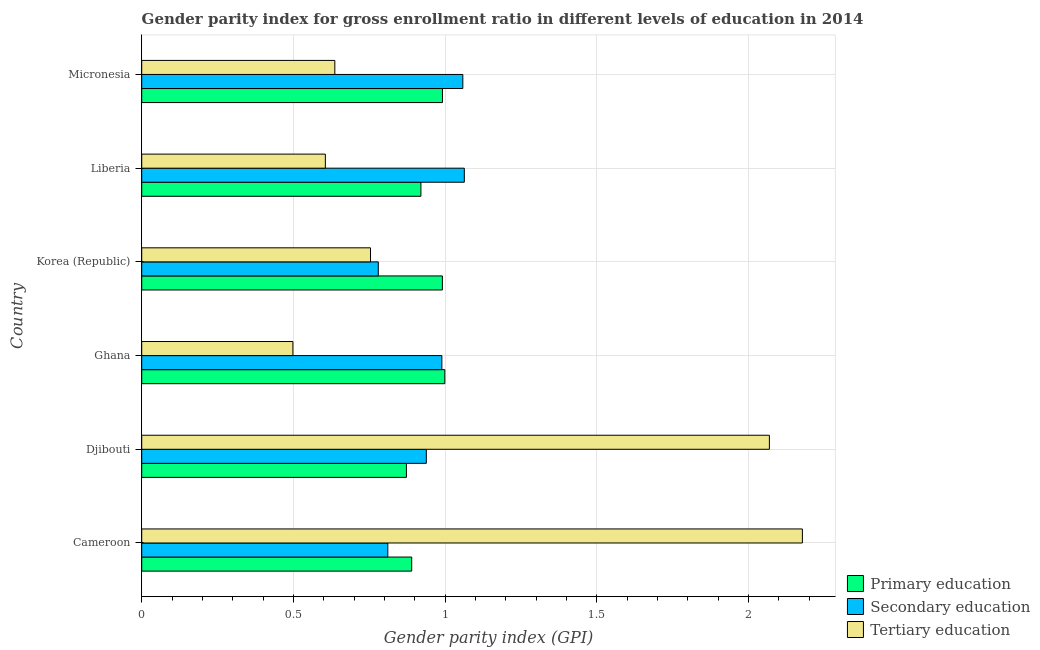How many different coloured bars are there?
Offer a very short reply. 3. Are the number of bars on each tick of the Y-axis equal?
Your answer should be compact. Yes. How many bars are there on the 4th tick from the top?
Keep it short and to the point. 3. How many bars are there on the 2nd tick from the bottom?
Provide a succinct answer. 3. What is the label of the 5th group of bars from the top?
Provide a succinct answer. Djibouti. What is the gender parity index in tertiary education in Micronesia?
Keep it short and to the point. 0.64. Across all countries, what is the maximum gender parity index in primary education?
Ensure brevity in your answer.  1. Across all countries, what is the minimum gender parity index in primary education?
Give a very brief answer. 0.87. In which country was the gender parity index in tertiary education maximum?
Your answer should be compact. Cameroon. What is the total gender parity index in primary education in the graph?
Provide a short and direct response. 5.66. What is the difference between the gender parity index in tertiary education in Cameroon and that in Korea (Republic)?
Keep it short and to the point. 1.42. What is the difference between the gender parity index in primary education in Djibouti and the gender parity index in secondary education in Liberia?
Ensure brevity in your answer.  -0.19. What is the average gender parity index in tertiary education per country?
Provide a short and direct response. 1.12. What is the difference between the gender parity index in tertiary education and gender parity index in secondary education in Liberia?
Ensure brevity in your answer.  -0.46. What is the ratio of the gender parity index in tertiary education in Ghana to that in Liberia?
Offer a terse response. 0.82. What is the difference between the highest and the second highest gender parity index in primary education?
Offer a terse response. 0.01. What is the difference between the highest and the lowest gender parity index in primary education?
Make the answer very short. 0.13. In how many countries, is the gender parity index in secondary education greater than the average gender parity index in secondary education taken over all countries?
Offer a terse response. 3. What does the 1st bar from the top in Djibouti represents?
Make the answer very short. Tertiary education. What does the 3rd bar from the bottom in Cameroon represents?
Your answer should be very brief. Tertiary education. How many bars are there?
Provide a succinct answer. 18. How many countries are there in the graph?
Ensure brevity in your answer.  6. What is the difference between two consecutive major ticks on the X-axis?
Give a very brief answer. 0.5. Are the values on the major ticks of X-axis written in scientific E-notation?
Ensure brevity in your answer.  No. Does the graph contain grids?
Ensure brevity in your answer.  Yes. How many legend labels are there?
Offer a terse response. 3. How are the legend labels stacked?
Your answer should be very brief. Vertical. What is the title of the graph?
Your answer should be very brief. Gender parity index for gross enrollment ratio in different levels of education in 2014. Does "Consumption Tax" appear as one of the legend labels in the graph?
Offer a terse response. No. What is the label or title of the X-axis?
Provide a succinct answer. Gender parity index (GPI). What is the Gender parity index (GPI) of Primary education in Cameroon?
Your response must be concise. 0.89. What is the Gender parity index (GPI) in Secondary education in Cameroon?
Offer a terse response. 0.81. What is the Gender parity index (GPI) of Tertiary education in Cameroon?
Provide a short and direct response. 2.18. What is the Gender parity index (GPI) in Primary education in Djibouti?
Your response must be concise. 0.87. What is the Gender parity index (GPI) in Secondary education in Djibouti?
Provide a succinct answer. 0.94. What is the Gender parity index (GPI) in Tertiary education in Djibouti?
Make the answer very short. 2.07. What is the Gender parity index (GPI) in Primary education in Ghana?
Give a very brief answer. 1. What is the Gender parity index (GPI) of Secondary education in Ghana?
Ensure brevity in your answer.  0.99. What is the Gender parity index (GPI) in Tertiary education in Ghana?
Your response must be concise. 0.5. What is the Gender parity index (GPI) in Primary education in Korea (Republic)?
Your answer should be very brief. 0.99. What is the Gender parity index (GPI) of Secondary education in Korea (Republic)?
Give a very brief answer. 0.78. What is the Gender parity index (GPI) of Tertiary education in Korea (Republic)?
Provide a succinct answer. 0.75. What is the Gender parity index (GPI) in Primary education in Liberia?
Your response must be concise. 0.92. What is the Gender parity index (GPI) in Secondary education in Liberia?
Make the answer very short. 1.06. What is the Gender parity index (GPI) in Tertiary education in Liberia?
Keep it short and to the point. 0.61. What is the Gender parity index (GPI) of Primary education in Micronesia?
Your answer should be compact. 0.99. What is the Gender parity index (GPI) of Secondary education in Micronesia?
Keep it short and to the point. 1.06. What is the Gender parity index (GPI) in Tertiary education in Micronesia?
Offer a terse response. 0.64. Across all countries, what is the maximum Gender parity index (GPI) in Primary education?
Give a very brief answer. 1. Across all countries, what is the maximum Gender parity index (GPI) of Secondary education?
Make the answer very short. 1.06. Across all countries, what is the maximum Gender parity index (GPI) of Tertiary education?
Provide a succinct answer. 2.18. Across all countries, what is the minimum Gender parity index (GPI) of Primary education?
Keep it short and to the point. 0.87. Across all countries, what is the minimum Gender parity index (GPI) of Secondary education?
Provide a short and direct response. 0.78. Across all countries, what is the minimum Gender parity index (GPI) in Tertiary education?
Offer a terse response. 0.5. What is the total Gender parity index (GPI) of Primary education in the graph?
Your answer should be very brief. 5.66. What is the total Gender parity index (GPI) in Secondary education in the graph?
Ensure brevity in your answer.  5.64. What is the total Gender parity index (GPI) of Tertiary education in the graph?
Provide a succinct answer. 6.74. What is the difference between the Gender parity index (GPI) in Primary education in Cameroon and that in Djibouti?
Keep it short and to the point. 0.02. What is the difference between the Gender parity index (GPI) in Secondary education in Cameroon and that in Djibouti?
Provide a short and direct response. -0.13. What is the difference between the Gender parity index (GPI) of Tertiary education in Cameroon and that in Djibouti?
Ensure brevity in your answer.  0.11. What is the difference between the Gender parity index (GPI) of Primary education in Cameroon and that in Ghana?
Make the answer very short. -0.11. What is the difference between the Gender parity index (GPI) in Secondary education in Cameroon and that in Ghana?
Offer a very short reply. -0.18. What is the difference between the Gender parity index (GPI) in Tertiary education in Cameroon and that in Ghana?
Ensure brevity in your answer.  1.68. What is the difference between the Gender parity index (GPI) in Primary education in Cameroon and that in Korea (Republic)?
Offer a terse response. -0.1. What is the difference between the Gender parity index (GPI) in Secondary education in Cameroon and that in Korea (Republic)?
Offer a terse response. 0.03. What is the difference between the Gender parity index (GPI) in Tertiary education in Cameroon and that in Korea (Republic)?
Offer a very short reply. 1.42. What is the difference between the Gender parity index (GPI) of Primary education in Cameroon and that in Liberia?
Provide a short and direct response. -0.03. What is the difference between the Gender parity index (GPI) in Secondary education in Cameroon and that in Liberia?
Offer a very short reply. -0.25. What is the difference between the Gender parity index (GPI) of Tertiary education in Cameroon and that in Liberia?
Keep it short and to the point. 1.57. What is the difference between the Gender parity index (GPI) of Primary education in Cameroon and that in Micronesia?
Provide a succinct answer. -0.1. What is the difference between the Gender parity index (GPI) in Secondary education in Cameroon and that in Micronesia?
Your response must be concise. -0.25. What is the difference between the Gender parity index (GPI) in Tertiary education in Cameroon and that in Micronesia?
Your answer should be very brief. 1.54. What is the difference between the Gender parity index (GPI) of Primary education in Djibouti and that in Ghana?
Your answer should be very brief. -0.13. What is the difference between the Gender parity index (GPI) of Secondary education in Djibouti and that in Ghana?
Offer a terse response. -0.05. What is the difference between the Gender parity index (GPI) of Tertiary education in Djibouti and that in Ghana?
Ensure brevity in your answer.  1.57. What is the difference between the Gender parity index (GPI) in Primary education in Djibouti and that in Korea (Republic)?
Ensure brevity in your answer.  -0.12. What is the difference between the Gender parity index (GPI) of Secondary education in Djibouti and that in Korea (Republic)?
Offer a very short reply. 0.16. What is the difference between the Gender parity index (GPI) of Tertiary education in Djibouti and that in Korea (Republic)?
Give a very brief answer. 1.31. What is the difference between the Gender parity index (GPI) in Primary education in Djibouti and that in Liberia?
Your response must be concise. -0.05. What is the difference between the Gender parity index (GPI) of Secondary education in Djibouti and that in Liberia?
Your answer should be very brief. -0.13. What is the difference between the Gender parity index (GPI) of Tertiary education in Djibouti and that in Liberia?
Keep it short and to the point. 1.46. What is the difference between the Gender parity index (GPI) in Primary education in Djibouti and that in Micronesia?
Ensure brevity in your answer.  -0.12. What is the difference between the Gender parity index (GPI) of Secondary education in Djibouti and that in Micronesia?
Your response must be concise. -0.12. What is the difference between the Gender parity index (GPI) in Tertiary education in Djibouti and that in Micronesia?
Offer a terse response. 1.43. What is the difference between the Gender parity index (GPI) of Primary education in Ghana and that in Korea (Republic)?
Provide a short and direct response. 0.01. What is the difference between the Gender parity index (GPI) of Secondary education in Ghana and that in Korea (Republic)?
Provide a succinct answer. 0.21. What is the difference between the Gender parity index (GPI) of Tertiary education in Ghana and that in Korea (Republic)?
Provide a short and direct response. -0.26. What is the difference between the Gender parity index (GPI) of Primary education in Ghana and that in Liberia?
Ensure brevity in your answer.  0.08. What is the difference between the Gender parity index (GPI) in Secondary education in Ghana and that in Liberia?
Your response must be concise. -0.07. What is the difference between the Gender parity index (GPI) of Tertiary education in Ghana and that in Liberia?
Offer a terse response. -0.11. What is the difference between the Gender parity index (GPI) of Primary education in Ghana and that in Micronesia?
Your answer should be very brief. 0.01. What is the difference between the Gender parity index (GPI) of Secondary education in Ghana and that in Micronesia?
Provide a short and direct response. -0.07. What is the difference between the Gender parity index (GPI) of Tertiary education in Ghana and that in Micronesia?
Your response must be concise. -0.14. What is the difference between the Gender parity index (GPI) in Primary education in Korea (Republic) and that in Liberia?
Give a very brief answer. 0.07. What is the difference between the Gender parity index (GPI) in Secondary education in Korea (Republic) and that in Liberia?
Your answer should be compact. -0.28. What is the difference between the Gender parity index (GPI) of Tertiary education in Korea (Republic) and that in Liberia?
Keep it short and to the point. 0.15. What is the difference between the Gender parity index (GPI) in Primary education in Korea (Republic) and that in Micronesia?
Offer a very short reply. -0. What is the difference between the Gender parity index (GPI) in Secondary education in Korea (Republic) and that in Micronesia?
Make the answer very short. -0.28. What is the difference between the Gender parity index (GPI) in Tertiary education in Korea (Republic) and that in Micronesia?
Give a very brief answer. 0.12. What is the difference between the Gender parity index (GPI) of Primary education in Liberia and that in Micronesia?
Keep it short and to the point. -0.07. What is the difference between the Gender parity index (GPI) in Secondary education in Liberia and that in Micronesia?
Make the answer very short. 0. What is the difference between the Gender parity index (GPI) in Tertiary education in Liberia and that in Micronesia?
Your answer should be compact. -0.03. What is the difference between the Gender parity index (GPI) of Primary education in Cameroon and the Gender parity index (GPI) of Secondary education in Djibouti?
Give a very brief answer. -0.05. What is the difference between the Gender parity index (GPI) in Primary education in Cameroon and the Gender parity index (GPI) in Tertiary education in Djibouti?
Your answer should be compact. -1.18. What is the difference between the Gender parity index (GPI) in Secondary education in Cameroon and the Gender parity index (GPI) in Tertiary education in Djibouti?
Offer a very short reply. -1.26. What is the difference between the Gender parity index (GPI) of Primary education in Cameroon and the Gender parity index (GPI) of Secondary education in Ghana?
Your answer should be compact. -0.1. What is the difference between the Gender parity index (GPI) of Primary education in Cameroon and the Gender parity index (GPI) of Tertiary education in Ghana?
Keep it short and to the point. 0.39. What is the difference between the Gender parity index (GPI) of Secondary education in Cameroon and the Gender parity index (GPI) of Tertiary education in Ghana?
Provide a short and direct response. 0.31. What is the difference between the Gender parity index (GPI) in Primary education in Cameroon and the Gender parity index (GPI) in Secondary education in Korea (Republic)?
Ensure brevity in your answer.  0.11. What is the difference between the Gender parity index (GPI) of Primary education in Cameroon and the Gender parity index (GPI) of Tertiary education in Korea (Republic)?
Make the answer very short. 0.14. What is the difference between the Gender parity index (GPI) of Secondary education in Cameroon and the Gender parity index (GPI) of Tertiary education in Korea (Republic)?
Your response must be concise. 0.06. What is the difference between the Gender parity index (GPI) of Primary education in Cameroon and the Gender parity index (GPI) of Secondary education in Liberia?
Provide a short and direct response. -0.17. What is the difference between the Gender parity index (GPI) of Primary education in Cameroon and the Gender parity index (GPI) of Tertiary education in Liberia?
Provide a short and direct response. 0.28. What is the difference between the Gender parity index (GPI) of Secondary education in Cameroon and the Gender parity index (GPI) of Tertiary education in Liberia?
Provide a succinct answer. 0.21. What is the difference between the Gender parity index (GPI) in Primary education in Cameroon and the Gender parity index (GPI) in Secondary education in Micronesia?
Your answer should be compact. -0.17. What is the difference between the Gender parity index (GPI) of Primary education in Cameroon and the Gender parity index (GPI) of Tertiary education in Micronesia?
Ensure brevity in your answer.  0.25. What is the difference between the Gender parity index (GPI) of Secondary education in Cameroon and the Gender parity index (GPI) of Tertiary education in Micronesia?
Your answer should be very brief. 0.17. What is the difference between the Gender parity index (GPI) of Primary education in Djibouti and the Gender parity index (GPI) of Secondary education in Ghana?
Give a very brief answer. -0.12. What is the difference between the Gender parity index (GPI) in Primary education in Djibouti and the Gender parity index (GPI) in Tertiary education in Ghana?
Your answer should be compact. 0.37. What is the difference between the Gender parity index (GPI) of Secondary education in Djibouti and the Gender parity index (GPI) of Tertiary education in Ghana?
Your answer should be compact. 0.44. What is the difference between the Gender parity index (GPI) in Primary education in Djibouti and the Gender parity index (GPI) in Secondary education in Korea (Republic)?
Offer a terse response. 0.09. What is the difference between the Gender parity index (GPI) in Primary education in Djibouti and the Gender parity index (GPI) in Tertiary education in Korea (Republic)?
Make the answer very short. 0.12. What is the difference between the Gender parity index (GPI) of Secondary education in Djibouti and the Gender parity index (GPI) of Tertiary education in Korea (Republic)?
Offer a very short reply. 0.18. What is the difference between the Gender parity index (GPI) of Primary education in Djibouti and the Gender parity index (GPI) of Secondary education in Liberia?
Give a very brief answer. -0.19. What is the difference between the Gender parity index (GPI) of Primary education in Djibouti and the Gender parity index (GPI) of Tertiary education in Liberia?
Your answer should be very brief. 0.27. What is the difference between the Gender parity index (GPI) in Secondary education in Djibouti and the Gender parity index (GPI) in Tertiary education in Liberia?
Offer a very short reply. 0.33. What is the difference between the Gender parity index (GPI) of Primary education in Djibouti and the Gender parity index (GPI) of Secondary education in Micronesia?
Provide a succinct answer. -0.19. What is the difference between the Gender parity index (GPI) in Primary education in Djibouti and the Gender parity index (GPI) in Tertiary education in Micronesia?
Your answer should be compact. 0.24. What is the difference between the Gender parity index (GPI) of Secondary education in Djibouti and the Gender parity index (GPI) of Tertiary education in Micronesia?
Offer a very short reply. 0.3. What is the difference between the Gender parity index (GPI) in Primary education in Ghana and the Gender parity index (GPI) in Secondary education in Korea (Republic)?
Offer a terse response. 0.22. What is the difference between the Gender parity index (GPI) in Primary education in Ghana and the Gender parity index (GPI) in Tertiary education in Korea (Republic)?
Your response must be concise. 0.24. What is the difference between the Gender parity index (GPI) of Secondary education in Ghana and the Gender parity index (GPI) of Tertiary education in Korea (Republic)?
Give a very brief answer. 0.24. What is the difference between the Gender parity index (GPI) of Primary education in Ghana and the Gender parity index (GPI) of Secondary education in Liberia?
Give a very brief answer. -0.06. What is the difference between the Gender parity index (GPI) of Primary education in Ghana and the Gender parity index (GPI) of Tertiary education in Liberia?
Your answer should be very brief. 0.39. What is the difference between the Gender parity index (GPI) in Secondary education in Ghana and the Gender parity index (GPI) in Tertiary education in Liberia?
Ensure brevity in your answer.  0.38. What is the difference between the Gender parity index (GPI) in Primary education in Ghana and the Gender parity index (GPI) in Secondary education in Micronesia?
Make the answer very short. -0.06. What is the difference between the Gender parity index (GPI) of Primary education in Ghana and the Gender parity index (GPI) of Tertiary education in Micronesia?
Keep it short and to the point. 0.36. What is the difference between the Gender parity index (GPI) of Secondary education in Ghana and the Gender parity index (GPI) of Tertiary education in Micronesia?
Your response must be concise. 0.35. What is the difference between the Gender parity index (GPI) of Primary education in Korea (Republic) and the Gender parity index (GPI) of Secondary education in Liberia?
Keep it short and to the point. -0.07. What is the difference between the Gender parity index (GPI) in Primary education in Korea (Republic) and the Gender parity index (GPI) in Tertiary education in Liberia?
Provide a succinct answer. 0.39. What is the difference between the Gender parity index (GPI) in Secondary education in Korea (Republic) and the Gender parity index (GPI) in Tertiary education in Liberia?
Make the answer very short. 0.17. What is the difference between the Gender parity index (GPI) of Primary education in Korea (Republic) and the Gender parity index (GPI) of Secondary education in Micronesia?
Provide a succinct answer. -0.07. What is the difference between the Gender parity index (GPI) of Primary education in Korea (Republic) and the Gender parity index (GPI) of Tertiary education in Micronesia?
Provide a short and direct response. 0.35. What is the difference between the Gender parity index (GPI) of Secondary education in Korea (Republic) and the Gender parity index (GPI) of Tertiary education in Micronesia?
Ensure brevity in your answer.  0.14. What is the difference between the Gender parity index (GPI) of Primary education in Liberia and the Gender parity index (GPI) of Secondary education in Micronesia?
Provide a succinct answer. -0.14. What is the difference between the Gender parity index (GPI) in Primary education in Liberia and the Gender parity index (GPI) in Tertiary education in Micronesia?
Offer a very short reply. 0.28. What is the difference between the Gender parity index (GPI) of Secondary education in Liberia and the Gender parity index (GPI) of Tertiary education in Micronesia?
Offer a terse response. 0.43. What is the average Gender parity index (GPI) in Primary education per country?
Ensure brevity in your answer.  0.94. What is the average Gender parity index (GPI) in Secondary education per country?
Offer a terse response. 0.94. What is the average Gender parity index (GPI) of Tertiary education per country?
Give a very brief answer. 1.12. What is the difference between the Gender parity index (GPI) in Primary education and Gender parity index (GPI) in Secondary education in Cameroon?
Offer a terse response. 0.08. What is the difference between the Gender parity index (GPI) of Primary education and Gender parity index (GPI) of Tertiary education in Cameroon?
Your response must be concise. -1.29. What is the difference between the Gender parity index (GPI) in Secondary education and Gender parity index (GPI) in Tertiary education in Cameroon?
Offer a very short reply. -1.37. What is the difference between the Gender parity index (GPI) in Primary education and Gender parity index (GPI) in Secondary education in Djibouti?
Ensure brevity in your answer.  -0.07. What is the difference between the Gender parity index (GPI) of Primary education and Gender parity index (GPI) of Tertiary education in Djibouti?
Offer a very short reply. -1.2. What is the difference between the Gender parity index (GPI) of Secondary education and Gender parity index (GPI) of Tertiary education in Djibouti?
Your answer should be compact. -1.13. What is the difference between the Gender parity index (GPI) of Primary education and Gender parity index (GPI) of Secondary education in Ghana?
Make the answer very short. 0.01. What is the difference between the Gender parity index (GPI) in Primary education and Gender parity index (GPI) in Tertiary education in Ghana?
Provide a succinct answer. 0.5. What is the difference between the Gender parity index (GPI) of Secondary education and Gender parity index (GPI) of Tertiary education in Ghana?
Your answer should be compact. 0.49. What is the difference between the Gender parity index (GPI) of Primary education and Gender parity index (GPI) of Secondary education in Korea (Republic)?
Offer a very short reply. 0.21. What is the difference between the Gender parity index (GPI) of Primary education and Gender parity index (GPI) of Tertiary education in Korea (Republic)?
Your answer should be compact. 0.24. What is the difference between the Gender parity index (GPI) of Secondary education and Gender parity index (GPI) of Tertiary education in Korea (Republic)?
Provide a succinct answer. 0.03. What is the difference between the Gender parity index (GPI) in Primary education and Gender parity index (GPI) in Secondary education in Liberia?
Keep it short and to the point. -0.14. What is the difference between the Gender parity index (GPI) in Primary education and Gender parity index (GPI) in Tertiary education in Liberia?
Your answer should be compact. 0.31. What is the difference between the Gender parity index (GPI) in Secondary education and Gender parity index (GPI) in Tertiary education in Liberia?
Provide a succinct answer. 0.46. What is the difference between the Gender parity index (GPI) of Primary education and Gender parity index (GPI) of Secondary education in Micronesia?
Provide a short and direct response. -0.07. What is the difference between the Gender parity index (GPI) in Primary education and Gender parity index (GPI) in Tertiary education in Micronesia?
Offer a terse response. 0.35. What is the difference between the Gender parity index (GPI) in Secondary education and Gender parity index (GPI) in Tertiary education in Micronesia?
Offer a terse response. 0.42. What is the ratio of the Gender parity index (GPI) in Secondary education in Cameroon to that in Djibouti?
Your response must be concise. 0.86. What is the ratio of the Gender parity index (GPI) in Tertiary education in Cameroon to that in Djibouti?
Offer a very short reply. 1.05. What is the ratio of the Gender parity index (GPI) in Primary education in Cameroon to that in Ghana?
Keep it short and to the point. 0.89. What is the ratio of the Gender parity index (GPI) in Secondary education in Cameroon to that in Ghana?
Provide a succinct answer. 0.82. What is the ratio of the Gender parity index (GPI) of Tertiary education in Cameroon to that in Ghana?
Your response must be concise. 4.37. What is the ratio of the Gender parity index (GPI) of Primary education in Cameroon to that in Korea (Republic)?
Provide a succinct answer. 0.9. What is the ratio of the Gender parity index (GPI) in Secondary education in Cameroon to that in Korea (Republic)?
Your response must be concise. 1.04. What is the ratio of the Gender parity index (GPI) in Tertiary education in Cameroon to that in Korea (Republic)?
Provide a short and direct response. 2.89. What is the ratio of the Gender parity index (GPI) of Secondary education in Cameroon to that in Liberia?
Give a very brief answer. 0.76. What is the ratio of the Gender parity index (GPI) of Tertiary education in Cameroon to that in Liberia?
Your response must be concise. 3.6. What is the ratio of the Gender parity index (GPI) of Primary education in Cameroon to that in Micronesia?
Offer a terse response. 0.9. What is the ratio of the Gender parity index (GPI) in Secondary education in Cameroon to that in Micronesia?
Provide a succinct answer. 0.77. What is the ratio of the Gender parity index (GPI) of Tertiary education in Cameroon to that in Micronesia?
Ensure brevity in your answer.  3.42. What is the ratio of the Gender parity index (GPI) in Primary education in Djibouti to that in Ghana?
Your response must be concise. 0.87. What is the ratio of the Gender parity index (GPI) of Secondary education in Djibouti to that in Ghana?
Ensure brevity in your answer.  0.95. What is the ratio of the Gender parity index (GPI) of Tertiary education in Djibouti to that in Ghana?
Offer a terse response. 4.15. What is the ratio of the Gender parity index (GPI) of Primary education in Djibouti to that in Korea (Republic)?
Ensure brevity in your answer.  0.88. What is the ratio of the Gender parity index (GPI) of Secondary education in Djibouti to that in Korea (Republic)?
Ensure brevity in your answer.  1.2. What is the ratio of the Gender parity index (GPI) of Tertiary education in Djibouti to that in Korea (Republic)?
Keep it short and to the point. 2.74. What is the ratio of the Gender parity index (GPI) of Primary education in Djibouti to that in Liberia?
Your answer should be compact. 0.95. What is the ratio of the Gender parity index (GPI) of Secondary education in Djibouti to that in Liberia?
Your response must be concise. 0.88. What is the ratio of the Gender parity index (GPI) of Tertiary education in Djibouti to that in Liberia?
Offer a very short reply. 3.42. What is the ratio of the Gender parity index (GPI) of Primary education in Djibouti to that in Micronesia?
Your answer should be very brief. 0.88. What is the ratio of the Gender parity index (GPI) of Secondary education in Djibouti to that in Micronesia?
Give a very brief answer. 0.89. What is the ratio of the Gender parity index (GPI) of Tertiary education in Djibouti to that in Micronesia?
Your response must be concise. 3.25. What is the ratio of the Gender parity index (GPI) of Primary education in Ghana to that in Korea (Republic)?
Your answer should be compact. 1.01. What is the ratio of the Gender parity index (GPI) of Secondary education in Ghana to that in Korea (Republic)?
Make the answer very short. 1.27. What is the ratio of the Gender parity index (GPI) in Tertiary education in Ghana to that in Korea (Republic)?
Provide a short and direct response. 0.66. What is the ratio of the Gender parity index (GPI) in Primary education in Ghana to that in Liberia?
Your answer should be compact. 1.09. What is the ratio of the Gender parity index (GPI) of Secondary education in Ghana to that in Liberia?
Make the answer very short. 0.93. What is the ratio of the Gender parity index (GPI) in Tertiary education in Ghana to that in Liberia?
Give a very brief answer. 0.82. What is the ratio of the Gender parity index (GPI) in Secondary education in Ghana to that in Micronesia?
Ensure brevity in your answer.  0.93. What is the ratio of the Gender parity index (GPI) of Tertiary education in Ghana to that in Micronesia?
Offer a terse response. 0.78. What is the ratio of the Gender parity index (GPI) of Primary education in Korea (Republic) to that in Liberia?
Provide a short and direct response. 1.08. What is the ratio of the Gender parity index (GPI) of Secondary education in Korea (Republic) to that in Liberia?
Provide a succinct answer. 0.73. What is the ratio of the Gender parity index (GPI) of Tertiary education in Korea (Republic) to that in Liberia?
Offer a terse response. 1.25. What is the ratio of the Gender parity index (GPI) of Secondary education in Korea (Republic) to that in Micronesia?
Offer a terse response. 0.74. What is the ratio of the Gender parity index (GPI) in Tertiary education in Korea (Republic) to that in Micronesia?
Offer a terse response. 1.18. What is the ratio of the Gender parity index (GPI) in Primary education in Liberia to that in Micronesia?
Your answer should be very brief. 0.93. What is the ratio of the Gender parity index (GPI) of Tertiary education in Liberia to that in Micronesia?
Your response must be concise. 0.95. What is the difference between the highest and the second highest Gender parity index (GPI) of Primary education?
Ensure brevity in your answer.  0.01. What is the difference between the highest and the second highest Gender parity index (GPI) in Secondary education?
Offer a terse response. 0. What is the difference between the highest and the second highest Gender parity index (GPI) of Tertiary education?
Provide a succinct answer. 0.11. What is the difference between the highest and the lowest Gender parity index (GPI) in Primary education?
Your response must be concise. 0.13. What is the difference between the highest and the lowest Gender parity index (GPI) in Secondary education?
Provide a short and direct response. 0.28. What is the difference between the highest and the lowest Gender parity index (GPI) in Tertiary education?
Your response must be concise. 1.68. 